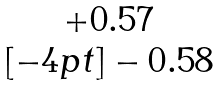<formula> <loc_0><loc_0><loc_500><loc_500>\begin{matrix} + 0 . 5 7 \\ [ - 4 p t ] - 0 . 5 8 \end{matrix}</formula> 